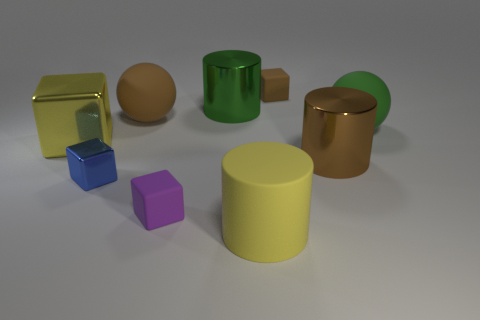Is there another block made of the same material as the yellow block? Yes, the cylindrical object appears to have a similar reflective surface, indicating it likely shares the same material. 